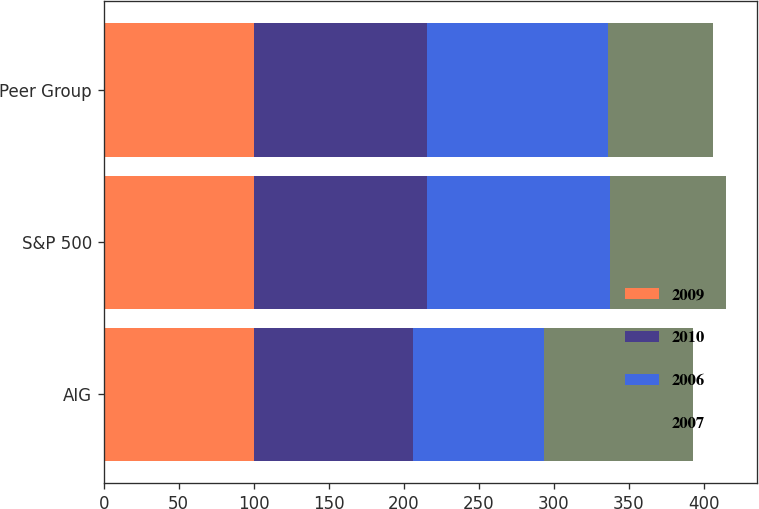Convert chart. <chart><loc_0><loc_0><loc_500><loc_500><stacked_bar_chart><ecel><fcel>AIG<fcel>S&P 500<fcel>Peer Group<nl><fcel>2009<fcel>100<fcel>100<fcel>100<nl><fcel>2010<fcel>106.05<fcel>115.79<fcel>115.71<nl><fcel>2006<fcel>87.24<fcel>122.16<fcel>120.86<nl><fcel>2007<fcel>100<fcel>76.96<fcel>69.93<nl></chart> 